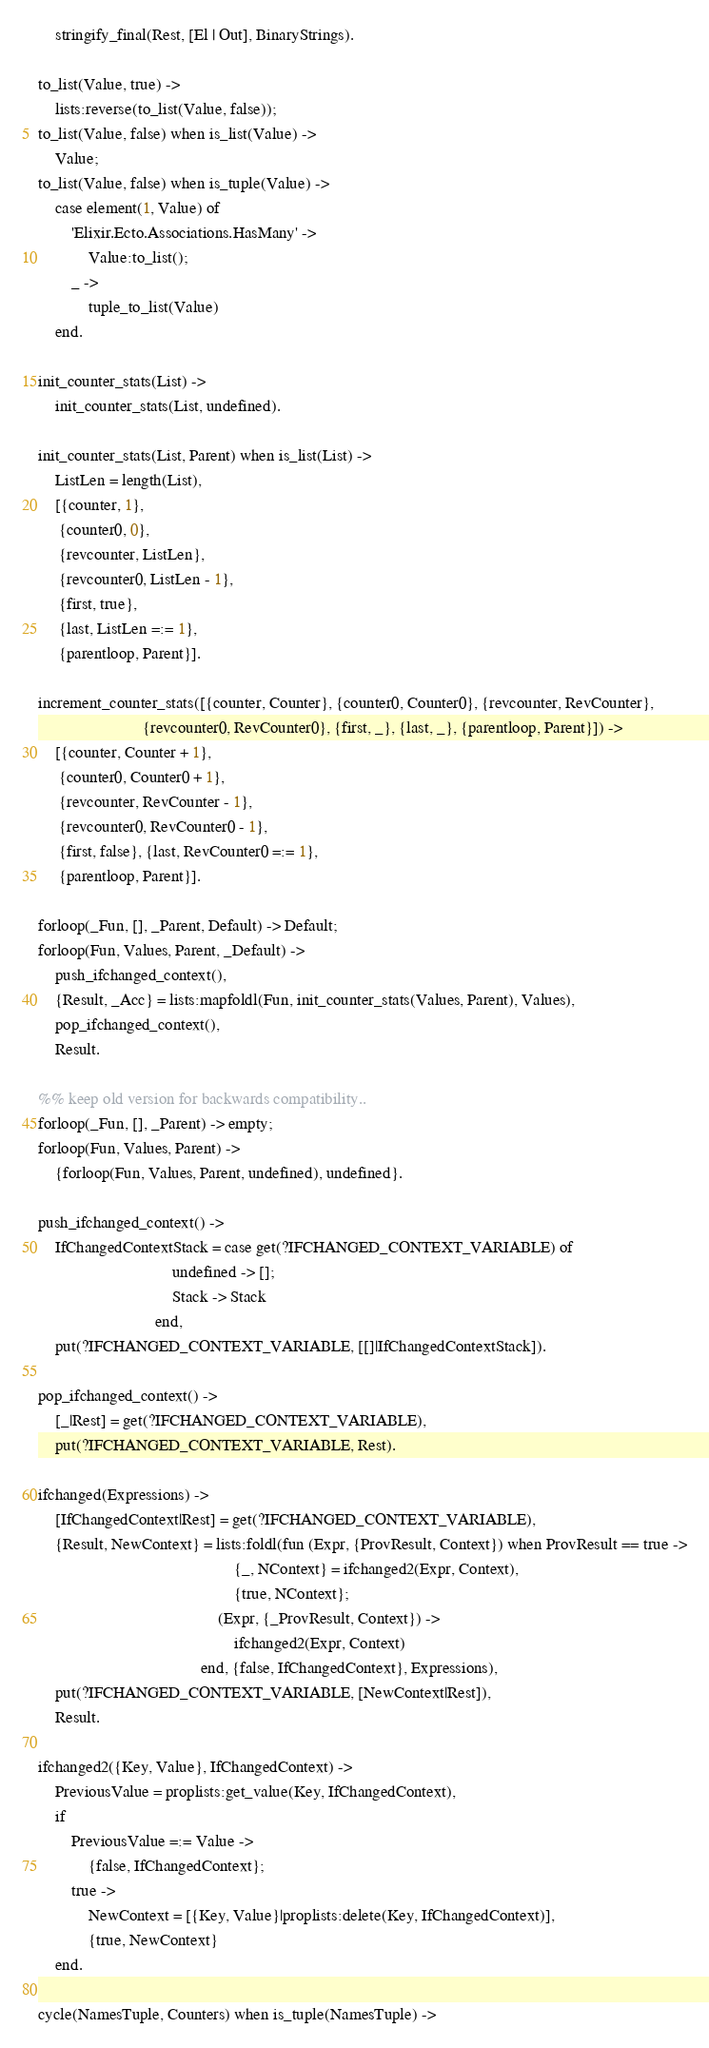<code> <loc_0><loc_0><loc_500><loc_500><_Erlang_>    stringify_final(Rest, [El | Out], BinaryStrings).

to_list(Value, true) ->
    lists:reverse(to_list(Value, false));
to_list(Value, false) when is_list(Value) ->
    Value;
to_list(Value, false) when is_tuple(Value) ->
    case element(1, Value) of
        'Elixir.Ecto.Associations.HasMany' ->
            Value:to_list();
        _ ->
            tuple_to_list(Value)
    end.

init_counter_stats(List) ->
    init_counter_stats(List, undefined).

init_counter_stats(List, Parent) when is_list(List) ->
    ListLen = length(List),
    [{counter, 1},
     {counter0, 0},
     {revcounter, ListLen},
     {revcounter0, ListLen - 1},
     {first, true},
     {last, ListLen =:= 1},
     {parentloop, Parent}].

increment_counter_stats([{counter, Counter}, {counter0, Counter0}, {revcounter, RevCounter},
                         {revcounter0, RevCounter0}, {first, _}, {last, _}, {parentloop, Parent}]) ->
    [{counter, Counter + 1},
     {counter0, Counter0 + 1},
     {revcounter, RevCounter - 1},
     {revcounter0, RevCounter0 - 1},
     {first, false}, {last, RevCounter0 =:= 1},
     {parentloop, Parent}].

forloop(_Fun, [], _Parent, Default) -> Default;
forloop(Fun, Values, Parent, _Default) ->
    push_ifchanged_context(),
    {Result, _Acc} = lists:mapfoldl(Fun, init_counter_stats(Values, Parent), Values),
    pop_ifchanged_context(),
    Result.

%% keep old version for backwards compatibility..
forloop(_Fun, [], _Parent) -> empty;
forloop(Fun, Values, Parent) ->
    {forloop(Fun, Values, Parent, undefined), undefined}.

push_ifchanged_context() ->
    IfChangedContextStack = case get(?IFCHANGED_CONTEXT_VARIABLE) of
                                undefined -> [];
                                Stack -> Stack
                            end,
    put(?IFCHANGED_CONTEXT_VARIABLE, [[]|IfChangedContextStack]).

pop_ifchanged_context() ->
    [_|Rest] = get(?IFCHANGED_CONTEXT_VARIABLE),
    put(?IFCHANGED_CONTEXT_VARIABLE, Rest).

ifchanged(Expressions) ->
    [IfChangedContext|Rest] = get(?IFCHANGED_CONTEXT_VARIABLE),
    {Result, NewContext} = lists:foldl(fun (Expr, {ProvResult, Context}) when ProvResult == true ->
                                               {_, NContext} = ifchanged2(Expr, Context),
                                               {true, NContext};
                                           (Expr, {_ProvResult, Context}) ->
                                               ifchanged2(Expr, Context)
                                       end, {false, IfChangedContext}, Expressions),
    put(?IFCHANGED_CONTEXT_VARIABLE, [NewContext|Rest]),
    Result.

ifchanged2({Key, Value}, IfChangedContext) ->
    PreviousValue = proplists:get_value(Key, IfChangedContext),
    if
        PreviousValue =:= Value ->
            {false, IfChangedContext};
        true ->
            NewContext = [{Key, Value}|proplists:delete(Key, IfChangedContext)],
            {true, NewContext}
    end.

cycle(NamesTuple, Counters) when is_tuple(NamesTuple) -></code> 